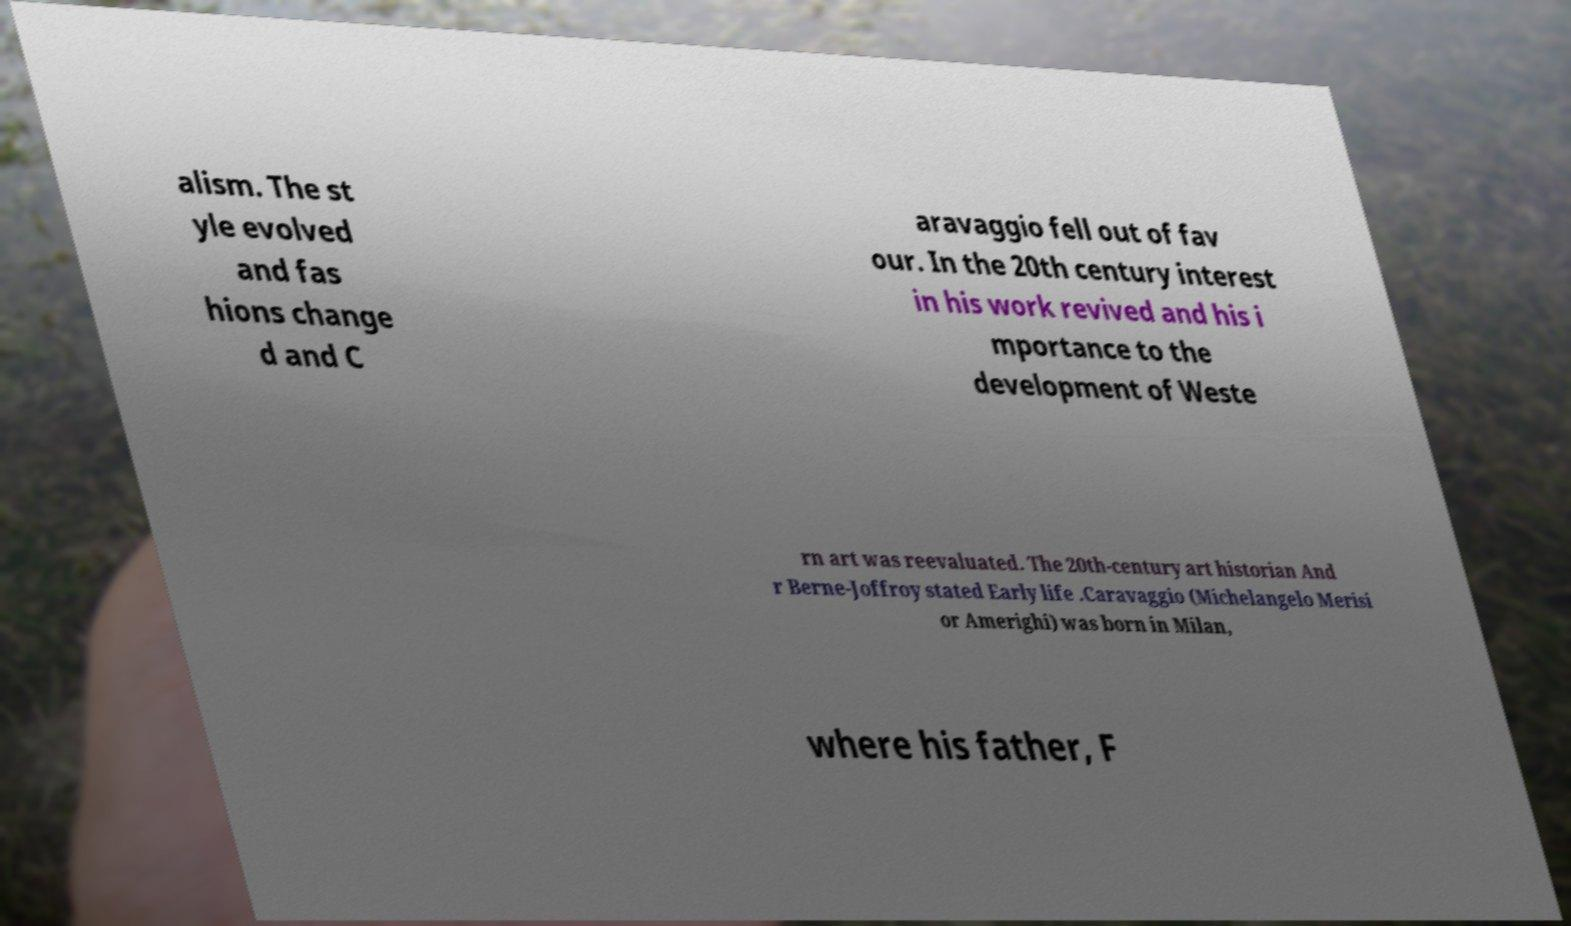Could you extract and type out the text from this image? alism. The st yle evolved and fas hions change d and C aravaggio fell out of fav our. In the 20th century interest in his work revived and his i mportance to the development of Weste rn art was reevaluated. The 20th-century art historian And r Berne-Joffroy stated Early life .Caravaggio (Michelangelo Merisi or Amerighi) was born in Milan, where his father, F 